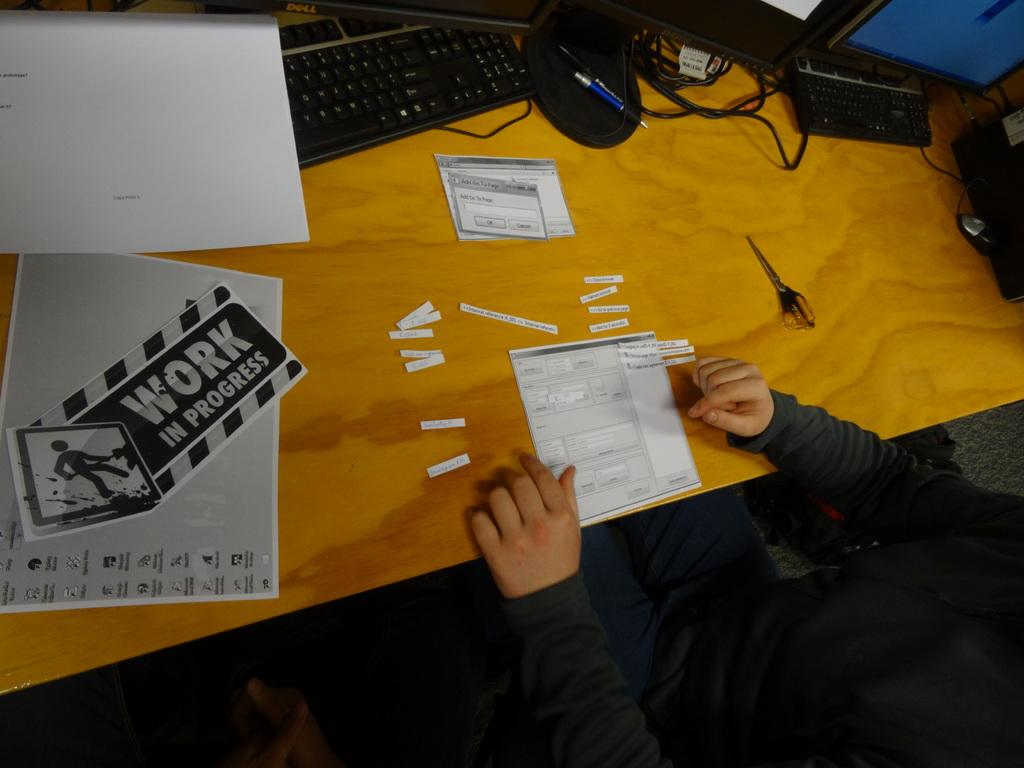<image>
Render a clear and concise summary of the photo. A wooden surface desk has computer details printed along with a work in progress sheet 